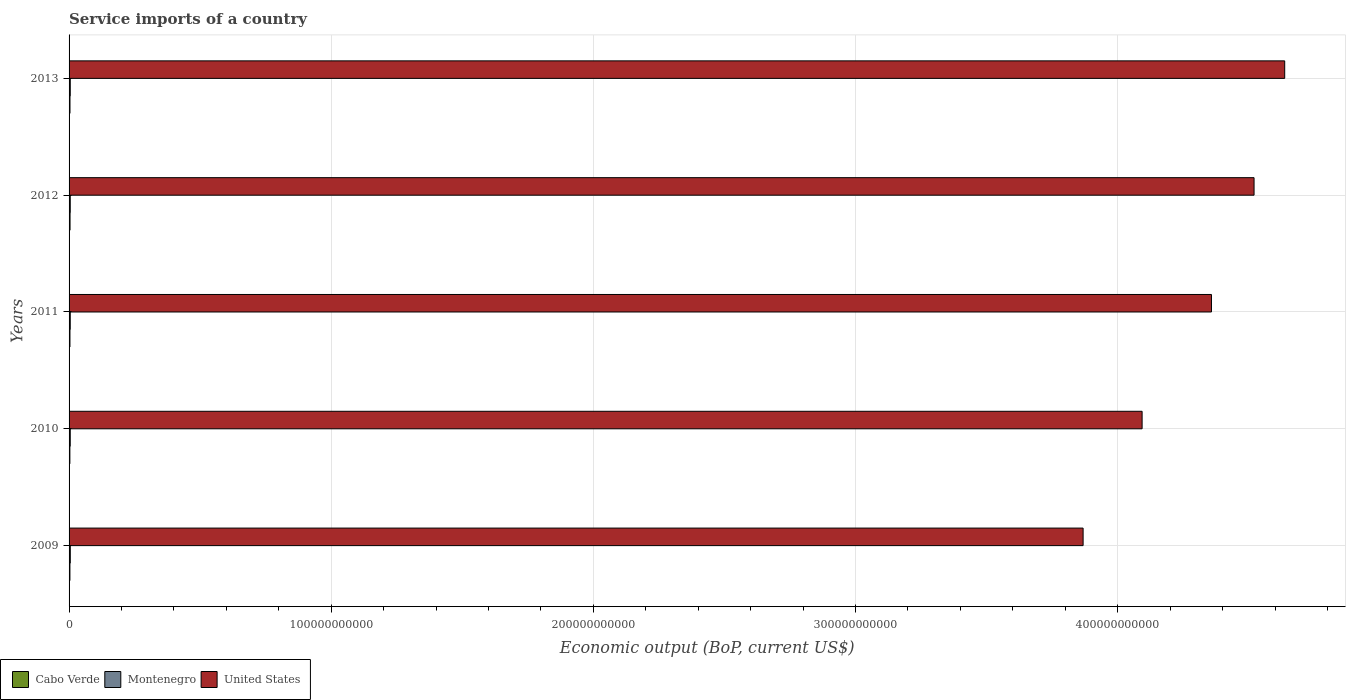Are the number of bars per tick equal to the number of legend labels?
Keep it short and to the point. Yes. Are the number of bars on each tick of the Y-axis equal?
Give a very brief answer. Yes. How many bars are there on the 4th tick from the bottom?
Ensure brevity in your answer.  3. What is the label of the 1st group of bars from the top?
Keep it short and to the point. 2013. In how many cases, is the number of bars for a given year not equal to the number of legend labels?
Offer a terse response. 0. What is the service imports in United States in 2009?
Your response must be concise. 3.87e+11. Across all years, what is the maximum service imports in United States?
Offer a terse response. 4.64e+11. Across all years, what is the minimum service imports in Cabo Verde?
Ensure brevity in your answer.  3.08e+08. What is the total service imports in Cabo Verde in the graph?
Your answer should be very brief. 1.69e+09. What is the difference between the service imports in United States in 2009 and that in 2013?
Offer a very short reply. -7.69e+1. What is the difference between the service imports in Montenegro in 2009 and the service imports in Cabo Verde in 2012?
Your response must be concise. 9.67e+07. What is the average service imports in United States per year?
Make the answer very short. 4.30e+11. In the year 2011, what is the difference between the service imports in United States and service imports in Montenegro?
Offer a terse response. 4.35e+11. What is the ratio of the service imports in Cabo Verde in 2009 to that in 2011?
Offer a very short reply. 0.98. Is the service imports in Montenegro in 2010 less than that in 2013?
Provide a succinct answer. Yes. Is the difference between the service imports in United States in 2012 and 2013 greater than the difference between the service imports in Montenegro in 2012 and 2013?
Ensure brevity in your answer.  No. What is the difference between the highest and the second highest service imports in United States?
Make the answer very short. 1.17e+1. What is the difference between the highest and the lowest service imports in United States?
Provide a succinct answer. 7.69e+1. What does the 1st bar from the bottom in 2013 represents?
Make the answer very short. Cabo Verde. How many bars are there?
Give a very brief answer. 15. Are all the bars in the graph horizontal?
Offer a very short reply. Yes. What is the difference between two consecutive major ticks on the X-axis?
Offer a terse response. 1.00e+11. Does the graph contain any zero values?
Give a very brief answer. No. Does the graph contain grids?
Make the answer very short. Yes. How many legend labels are there?
Give a very brief answer. 3. How are the legend labels stacked?
Give a very brief answer. Horizontal. What is the title of the graph?
Your answer should be very brief. Service imports of a country. What is the label or title of the X-axis?
Your answer should be compact. Economic output (BoP, current US$). What is the label or title of the Y-axis?
Provide a succinct answer. Years. What is the Economic output (BoP, current US$) of Cabo Verde in 2009?
Give a very brief answer. 3.26e+08. What is the Economic output (BoP, current US$) of Montenegro in 2009?
Ensure brevity in your answer.  4.67e+08. What is the Economic output (BoP, current US$) of United States in 2009?
Your answer should be very brief. 3.87e+11. What is the Economic output (BoP, current US$) of Cabo Verde in 2010?
Give a very brief answer. 3.08e+08. What is the Economic output (BoP, current US$) in Montenegro in 2010?
Offer a very short reply. 4.51e+08. What is the Economic output (BoP, current US$) in United States in 2010?
Keep it short and to the point. 4.09e+11. What is the Economic output (BoP, current US$) in Cabo Verde in 2011?
Your answer should be compact. 3.34e+08. What is the Economic output (BoP, current US$) in Montenegro in 2011?
Your response must be concise. 4.48e+08. What is the Economic output (BoP, current US$) of United States in 2011?
Your answer should be compact. 4.36e+11. What is the Economic output (BoP, current US$) in Cabo Verde in 2012?
Ensure brevity in your answer.  3.70e+08. What is the Economic output (BoP, current US$) of Montenegro in 2012?
Offer a very short reply. 4.49e+08. What is the Economic output (BoP, current US$) of United States in 2012?
Offer a very short reply. 4.52e+11. What is the Economic output (BoP, current US$) of Cabo Verde in 2013?
Keep it short and to the point. 3.49e+08. What is the Economic output (BoP, current US$) in Montenegro in 2013?
Provide a short and direct response. 4.53e+08. What is the Economic output (BoP, current US$) of United States in 2013?
Ensure brevity in your answer.  4.64e+11. Across all years, what is the maximum Economic output (BoP, current US$) of Cabo Verde?
Your answer should be very brief. 3.70e+08. Across all years, what is the maximum Economic output (BoP, current US$) in Montenegro?
Offer a terse response. 4.67e+08. Across all years, what is the maximum Economic output (BoP, current US$) in United States?
Provide a succinct answer. 4.64e+11. Across all years, what is the minimum Economic output (BoP, current US$) in Cabo Verde?
Offer a very short reply. 3.08e+08. Across all years, what is the minimum Economic output (BoP, current US$) in Montenegro?
Provide a succinct answer. 4.48e+08. Across all years, what is the minimum Economic output (BoP, current US$) in United States?
Ensure brevity in your answer.  3.87e+11. What is the total Economic output (BoP, current US$) of Cabo Verde in the graph?
Your response must be concise. 1.69e+09. What is the total Economic output (BoP, current US$) of Montenegro in the graph?
Your answer should be very brief. 2.27e+09. What is the total Economic output (BoP, current US$) of United States in the graph?
Ensure brevity in your answer.  2.15e+12. What is the difference between the Economic output (BoP, current US$) in Cabo Verde in 2009 and that in 2010?
Your response must be concise. 1.81e+07. What is the difference between the Economic output (BoP, current US$) of Montenegro in 2009 and that in 2010?
Make the answer very short. 1.63e+07. What is the difference between the Economic output (BoP, current US$) of United States in 2009 and that in 2010?
Provide a succinct answer. -2.25e+1. What is the difference between the Economic output (BoP, current US$) of Cabo Verde in 2009 and that in 2011?
Your response must be concise. -7.69e+06. What is the difference between the Economic output (BoP, current US$) in Montenegro in 2009 and that in 2011?
Ensure brevity in your answer.  1.94e+07. What is the difference between the Economic output (BoP, current US$) in United States in 2009 and that in 2011?
Ensure brevity in your answer.  -4.90e+1. What is the difference between the Economic output (BoP, current US$) in Cabo Verde in 2009 and that in 2012?
Offer a very short reply. -4.42e+07. What is the difference between the Economic output (BoP, current US$) in Montenegro in 2009 and that in 2012?
Provide a short and direct response. 1.80e+07. What is the difference between the Economic output (BoP, current US$) in United States in 2009 and that in 2012?
Offer a very short reply. -6.52e+1. What is the difference between the Economic output (BoP, current US$) in Cabo Verde in 2009 and that in 2013?
Your answer should be very brief. -2.28e+07. What is the difference between the Economic output (BoP, current US$) of Montenegro in 2009 and that in 2013?
Provide a short and direct response. 1.38e+07. What is the difference between the Economic output (BoP, current US$) in United States in 2009 and that in 2013?
Your answer should be very brief. -7.69e+1. What is the difference between the Economic output (BoP, current US$) in Cabo Verde in 2010 and that in 2011?
Your response must be concise. -2.58e+07. What is the difference between the Economic output (BoP, current US$) in Montenegro in 2010 and that in 2011?
Give a very brief answer. 3.09e+06. What is the difference between the Economic output (BoP, current US$) of United States in 2010 and that in 2011?
Your answer should be very brief. -2.65e+1. What is the difference between the Economic output (BoP, current US$) of Cabo Verde in 2010 and that in 2012?
Keep it short and to the point. -6.23e+07. What is the difference between the Economic output (BoP, current US$) in Montenegro in 2010 and that in 2012?
Keep it short and to the point. 1.73e+06. What is the difference between the Economic output (BoP, current US$) in United States in 2010 and that in 2012?
Make the answer very short. -4.27e+1. What is the difference between the Economic output (BoP, current US$) of Cabo Verde in 2010 and that in 2013?
Offer a terse response. -4.09e+07. What is the difference between the Economic output (BoP, current US$) in Montenegro in 2010 and that in 2013?
Your answer should be very brief. -2.53e+06. What is the difference between the Economic output (BoP, current US$) in United States in 2010 and that in 2013?
Make the answer very short. -5.44e+1. What is the difference between the Economic output (BoP, current US$) in Cabo Verde in 2011 and that in 2012?
Provide a succinct answer. -3.65e+07. What is the difference between the Economic output (BoP, current US$) in Montenegro in 2011 and that in 2012?
Provide a short and direct response. -1.36e+06. What is the difference between the Economic output (BoP, current US$) of United States in 2011 and that in 2012?
Ensure brevity in your answer.  -1.62e+1. What is the difference between the Economic output (BoP, current US$) of Cabo Verde in 2011 and that in 2013?
Ensure brevity in your answer.  -1.51e+07. What is the difference between the Economic output (BoP, current US$) in Montenegro in 2011 and that in 2013?
Offer a terse response. -5.62e+06. What is the difference between the Economic output (BoP, current US$) in United States in 2011 and that in 2013?
Offer a terse response. -2.79e+1. What is the difference between the Economic output (BoP, current US$) of Cabo Verde in 2012 and that in 2013?
Provide a succinct answer. 2.14e+07. What is the difference between the Economic output (BoP, current US$) in Montenegro in 2012 and that in 2013?
Offer a very short reply. -4.26e+06. What is the difference between the Economic output (BoP, current US$) in United States in 2012 and that in 2013?
Provide a short and direct response. -1.17e+1. What is the difference between the Economic output (BoP, current US$) of Cabo Verde in 2009 and the Economic output (BoP, current US$) of Montenegro in 2010?
Offer a terse response. -1.25e+08. What is the difference between the Economic output (BoP, current US$) in Cabo Verde in 2009 and the Economic output (BoP, current US$) in United States in 2010?
Provide a succinct answer. -4.09e+11. What is the difference between the Economic output (BoP, current US$) in Montenegro in 2009 and the Economic output (BoP, current US$) in United States in 2010?
Make the answer very short. -4.09e+11. What is the difference between the Economic output (BoP, current US$) of Cabo Verde in 2009 and the Economic output (BoP, current US$) of Montenegro in 2011?
Keep it short and to the point. -1.22e+08. What is the difference between the Economic output (BoP, current US$) of Cabo Verde in 2009 and the Economic output (BoP, current US$) of United States in 2011?
Keep it short and to the point. -4.35e+11. What is the difference between the Economic output (BoP, current US$) of Montenegro in 2009 and the Economic output (BoP, current US$) of United States in 2011?
Offer a very short reply. -4.35e+11. What is the difference between the Economic output (BoP, current US$) of Cabo Verde in 2009 and the Economic output (BoP, current US$) of Montenegro in 2012?
Ensure brevity in your answer.  -1.23e+08. What is the difference between the Economic output (BoP, current US$) of Cabo Verde in 2009 and the Economic output (BoP, current US$) of United States in 2012?
Make the answer very short. -4.52e+11. What is the difference between the Economic output (BoP, current US$) of Montenegro in 2009 and the Economic output (BoP, current US$) of United States in 2012?
Keep it short and to the point. -4.52e+11. What is the difference between the Economic output (BoP, current US$) in Cabo Verde in 2009 and the Economic output (BoP, current US$) in Montenegro in 2013?
Provide a short and direct response. -1.27e+08. What is the difference between the Economic output (BoP, current US$) in Cabo Verde in 2009 and the Economic output (BoP, current US$) in United States in 2013?
Offer a terse response. -4.63e+11. What is the difference between the Economic output (BoP, current US$) in Montenegro in 2009 and the Economic output (BoP, current US$) in United States in 2013?
Provide a short and direct response. -4.63e+11. What is the difference between the Economic output (BoP, current US$) of Cabo Verde in 2010 and the Economic output (BoP, current US$) of Montenegro in 2011?
Make the answer very short. -1.40e+08. What is the difference between the Economic output (BoP, current US$) in Cabo Verde in 2010 and the Economic output (BoP, current US$) in United States in 2011?
Provide a short and direct response. -4.35e+11. What is the difference between the Economic output (BoP, current US$) in Montenegro in 2010 and the Economic output (BoP, current US$) in United States in 2011?
Keep it short and to the point. -4.35e+11. What is the difference between the Economic output (BoP, current US$) in Cabo Verde in 2010 and the Economic output (BoP, current US$) in Montenegro in 2012?
Offer a very short reply. -1.41e+08. What is the difference between the Economic output (BoP, current US$) in Cabo Verde in 2010 and the Economic output (BoP, current US$) in United States in 2012?
Offer a very short reply. -4.52e+11. What is the difference between the Economic output (BoP, current US$) of Montenegro in 2010 and the Economic output (BoP, current US$) of United States in 2012?
Your response must be concise. -4.52e+11. What is the difference between the Economic output (BoP, current US$) in Cabo Verde in 2010 and the Economic output (BoP, current US$) in Montenegro in 2013?
Make the answer very short. -1.45e+08. What is the difference between the Economic output (BoP, current US$) of Cabo Verde in 2010 and the Economic output (BoP, current US$) of United States in 2013?
Give a very brief answer. -4.63e+11. What is the difference between the Economic output (BoP, current US$) of Montenegro in 2010 and the Economic output (BoP, current US$) of United States in 2013?
Your response must be concise. -4.63e+11. What is the difference between the Economic output (BoP, current US$) in Cabo Verde in 2011 and the Economic output (BoP, current US$) in Montenegro in 2012?
Make the answer very short. -1.15e+08. What is the difference between the Economic output (BoP, current US$) of Cabo Verde in 2011 and the Economic output (BoP, current US$) of United States in 2012?
Your answer should be compact. -4.52e+11. What is the difference between the Economic output (BoP, current US$) in Montenegro in 2011 and the Economic output (BoP, current US$) in United States in 2012?
Keep it short and to the point. -4.52e+11. What is the difference between the Economic output (BoP, current US$) of Cabo Verde in 2011 and the Economic output (BoP, current US$) of Montenegro in 2013?
Provide a short and direct response. -1.20e+08. What is the difference between the Economic output (BoP, current US$) in Cabo Verde in 2011 and the Economic output (BoP, current US$) in United States in 2013?
Keep it short and to the point. -4.63e+11. What is the difference between the Economic output (BoP, current US$) of Montenegro in 2011 and the Economic output (BoP, current US$) of United States in 2013?
Give a very brief answer. -4.63e+11. What is the difference between the Economic output (BoP, current US$) in Cabo Verde in 2012 and the Economic output (BoP, current US$) in Montenegro in 2013?
Make the answer very short. -8.30e+07. What is the difference between the Economic output (BoP, current US$) in Cabo Verde in 2012 and the Economic output (BoP, current US$) in United States in 2013?
Your answer should be very brief. -4.63e+11. What is the difference between the Economic output (BoP, current US$) of Montenegro in 2012 and the Economic output (BoP, current US$) of United States in 2013?
Provide a succinct answer. -4.63e+11. What is the average Economic output (BoP, current US$) in Cabo Verde per year?
Your response must be concise. 3.37e+08. What is the average Economic output (BoP, current US$) in Montenegro per year?
Your response must be concise. 4.53e+08. What is the average Economic output (BoP, current US$) of United States per year?
Provide a short and direct response. 4.30e+11. In the year 2009, what is the difference between the Economic output (BoP, current US$) in Cabo Verde and Economic output (BoP, current US$) in Montenegro?
Keep it short and to the point. -1.41e+08. In the year 2009, what is the difference between the Economic output (BoP, current US$) in Cabo Verde and Economic output (BoP, current US$) in United States?
Ensure brevity in your answer.  -3.86e+11. In the year 2009, what is the difference between the Economic output (BoP, current US$) of Montenegro and Economic output (BoP, current US$) of United States?
Ensure brevity in your answer.  -3.86e+11. In the year 2010, what is the difference between the Economic output (BoP, current US$) in Cabo Verde and Economic output (BoP, current US$) in Montenegro?
Provide a short and direct response. -1.43e+08. In the year 2010, what is the difference between the Economic output (BoP, current US$) of Cabo Verde and Economic output (BoP, current US$) of United States?
Provide a short and direct response. -4.09e+11. In the year 2010, what is the difference between the Economic output (BoP, current US$) in Montenegro and Economic output (BoP, current US$) in United States?
Your answer should be compact. -4.09e+11. In the year 2011, what is the difference between the Economic output (BoP, current US$) in Cabo Verde and Economic output (BoP, current US$) in Montenegro?
Your answer should be very brief. -1.14e+08. In the year 2011, what is the difference between the Economic output (BoP, current US$) in Cabo Verde and Economic output (BoP, current US$) in United States?
Make the answer very short. -4.35e+11. In the year 2011, what is the difference between the Economic output (BoP, current US$) in Montenegro and Economic output (BoP, current US$) in United States?
Your response must be concise. -4.35e+11. In the year 2012, what is the difference between the Economic output (BoP, current US$) of Cabo Verde and Economic output (BoP, current US$) of Montenegro?
Provide a succinct answer. -7.87e+07. In the year 2012, what is the difference between the Economic output (BoP, current US$) in Cabo Verde and Economic output (BoP, current US$) in United States?
Your answer should be very brief. -4.52e+11. In the year 2012, what is the difference between the Economic output (BoP, current US$) of Montenegro and Economic output (BoP, current US$) of United States?
Make the answer very short. -4.52e+11. In the year 2013, what is the difference between the Economic output (BoP, current US$) of Cabo Verde and Economic output (BoP, current US$) of Montenegro?
Offer a very short reply. -1.04e+08. In the year 2013, what is the difference between the Economic output (BoP, current US$) in Cabo Verde and Economic output (BoP, current US$) in United States?
Your answer should be very brief. -4.63e+11. In the year 2013, what is the difference between the Economic output (BoP, current US$) of Montenegro and Economic output (BoP, current US$) of United States?
Provide a short and direct response. -4.63e+11. What is the ratio of the Economic output (BoP, current US$) in Cabo Verde in 2009 to that in 2010?
Give a very brief answer. 1.06. What is the ratio of the Economic output (BoP, current US$) in Montenegro in 2009 to that in 2010?
Make the answer very short. 1.04. What is the ratio of the Economic output (BoP, current US$) in United States in 2009 to that in 2010?
Provide a succinct answer. 0.94. What is the ratio of the Economic output (BoP, current US$) of Cabo Verde in 2009 to that in 2011?
Keep it short and to the point. 0.98. What is the ratio of the Economic output (BoP, current US$) of Montenegro in 2009 to that in 2011?
Provide a short and direct response. 1.04. What is the ratio of the Economic output (BoP, current US$) in United States in 2009 to that in 2011?
Offer a very short reply. 0.89. What is the ratio of the Economic output (BoP, current US$) of Cabo Verde in 2009 to that in 2012?
Your response must be concise. 0.88. What is the ratio of the Economic output (BoP, current US$) in Montenegro in 2009 to that in 2012?
Keep it short and to the point. 1.04. What is the ratio of the Economic output (BoP, current US$) of United States in 2009 to that in 2012?
Provide a succinct answer. 0.86. What is the ratio of the Economic output (BoP, current US$) in Cabo Verde in 2009 to that in 2013?
Offer a very short reply. 0.93. What is the ratio of the Economic output (BoP, current US$) of Montenegro in 2009 to that in 2013?
Provide a short and direct response. 1.03. What is the ratio of the Economic output (BoP, current US$) in United States in 2009 to that in 2013?
Your answer should be very brief. 0.83. What is the ratio of the Economic output (BoP, current US$) of Cabo Verde in 2010 to that in 2011?
Offer a terse response. 0.92. What is the ratio of the Economic output (BoP, current US$) in United States in 2010 to that in 2011?
Your answer should be very brief. 0.94. What is the ratio of the Economic output (BoP, current US$) in Cabo Verde in 2010 to that in 2012?
Your answer should be compact. 0.83. What is the ratio of the Economic output (BoP, current US$) of United States in 2010 to that in 2012?
Your answer should be compact. 0.91. What is the ratio of the Economic output (BoP, current US$) of Cabo Verde in 2010 to that in 2013?
Provide a short and direct response. 0.88. What is the ratio of the Economic output (BoP, current US$) of United States in 2010 to that in 2013?
Give a very brief answer. 0.88. What is the ratio of the Economic output (BoP, current US$) in Cabo Verde in 2011 to that in 2012?
Provide a short and direct response. 0.9. What is the ratio of the Economic output (BoP, current US$) of United States in 2011 to that in 2012?
Keep it short and to the point. 0.96. What is the ratio of the Economic output (BoP, current US$) of Cabo Verde in 2011 to that in 2013?
Provide a short and direct response. 0.96. What is the ratio of the Economic output (BoP, current US$) in Montenegro in 2011 to that in 2013?
Give a very brief answer. 0.99. What is the ratio of the Economic output (BoP, current US$) in United States in 2011 to that in 2013?
Give a very brief answer. 0.94. What is the ratio of the Economic output (BoP, current US$) in Cabo Verde in 2012 to that in 2013?
Ensure brevity in your answer.  1.06. What is the ratio of the Economic output (BoP, current US$) in Montenegro in 2012 to that in 2013?
Your response must be concise. 0.99. What is the ratio of the Economic output (BoP, current US$) in United States in 2012 to that in 2013?
Offer a terse response. 0.97. What is the difference between the highest and the second highest Economic output (BoP, current US$) of Cabo Verde?
Offer a terse response. 2.14e+07. What is the difference between the highest and the second highest Economic output (BoP, current US$) in Montenegro?
Your response must be concise. 1.38e+07. What is the difference between the highest and the second highest Economic output (BoP, current US$) of United States?
Keep it short and to the point. 1.17e+1. What is the difference between the highest and the lowest Economic output (BoP, current US$) in Cabo Verde?
Your answer should be compact. 6.23e+07. What is the difference between the highest and the lowest Economic output (BoP, current US$) of Montenegro?
Keep it short and to the point. 1.94e+07. What is the difference between the highest and the lowest Economic output (BoP, current US$) of United States?
Offer a terse response. 7.69e+1. 